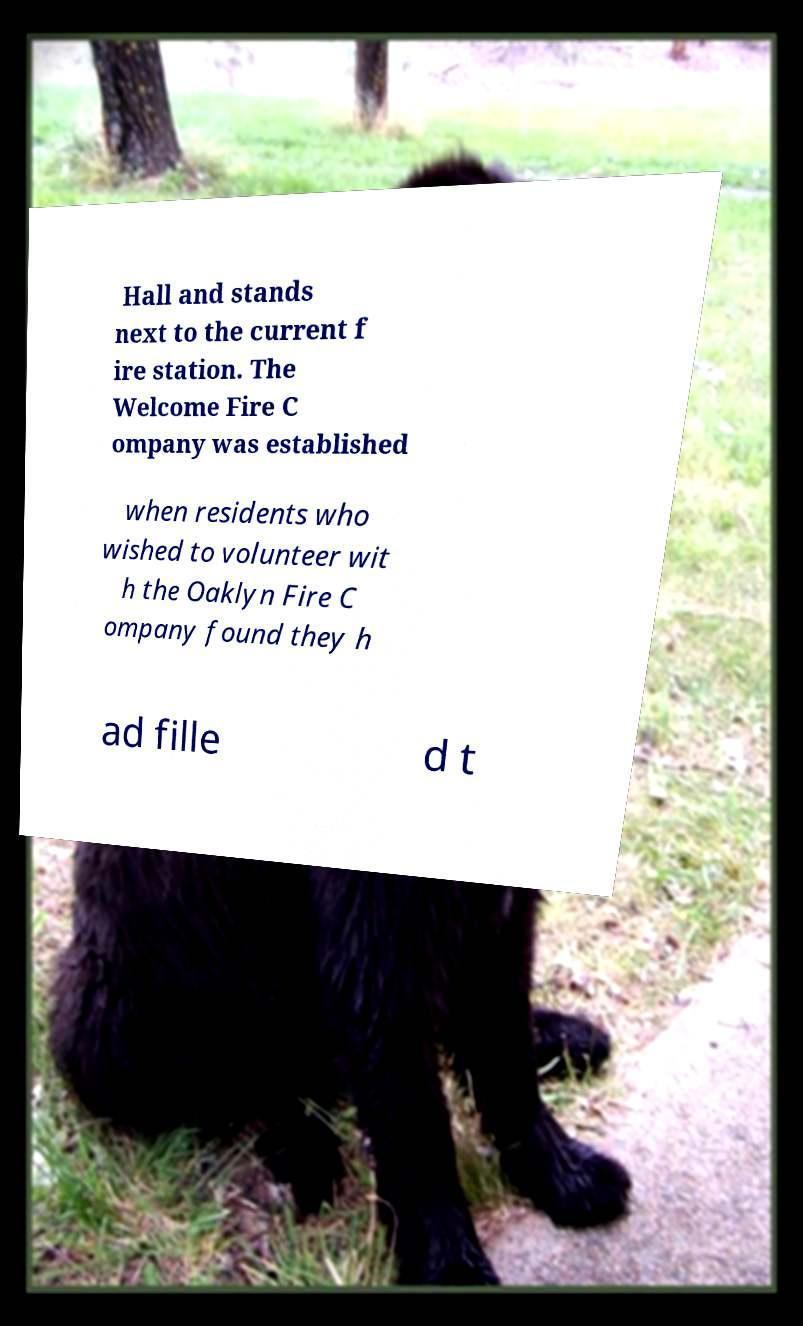What messages or text are displayed in this image? I need them in a readable, typed format. Hall and stands next to the current f ire station. The Welcome Fire C ompany was established when residents who wished to volunteer wit h the Oaklyn Fire C ompany found they h ad fille d t 